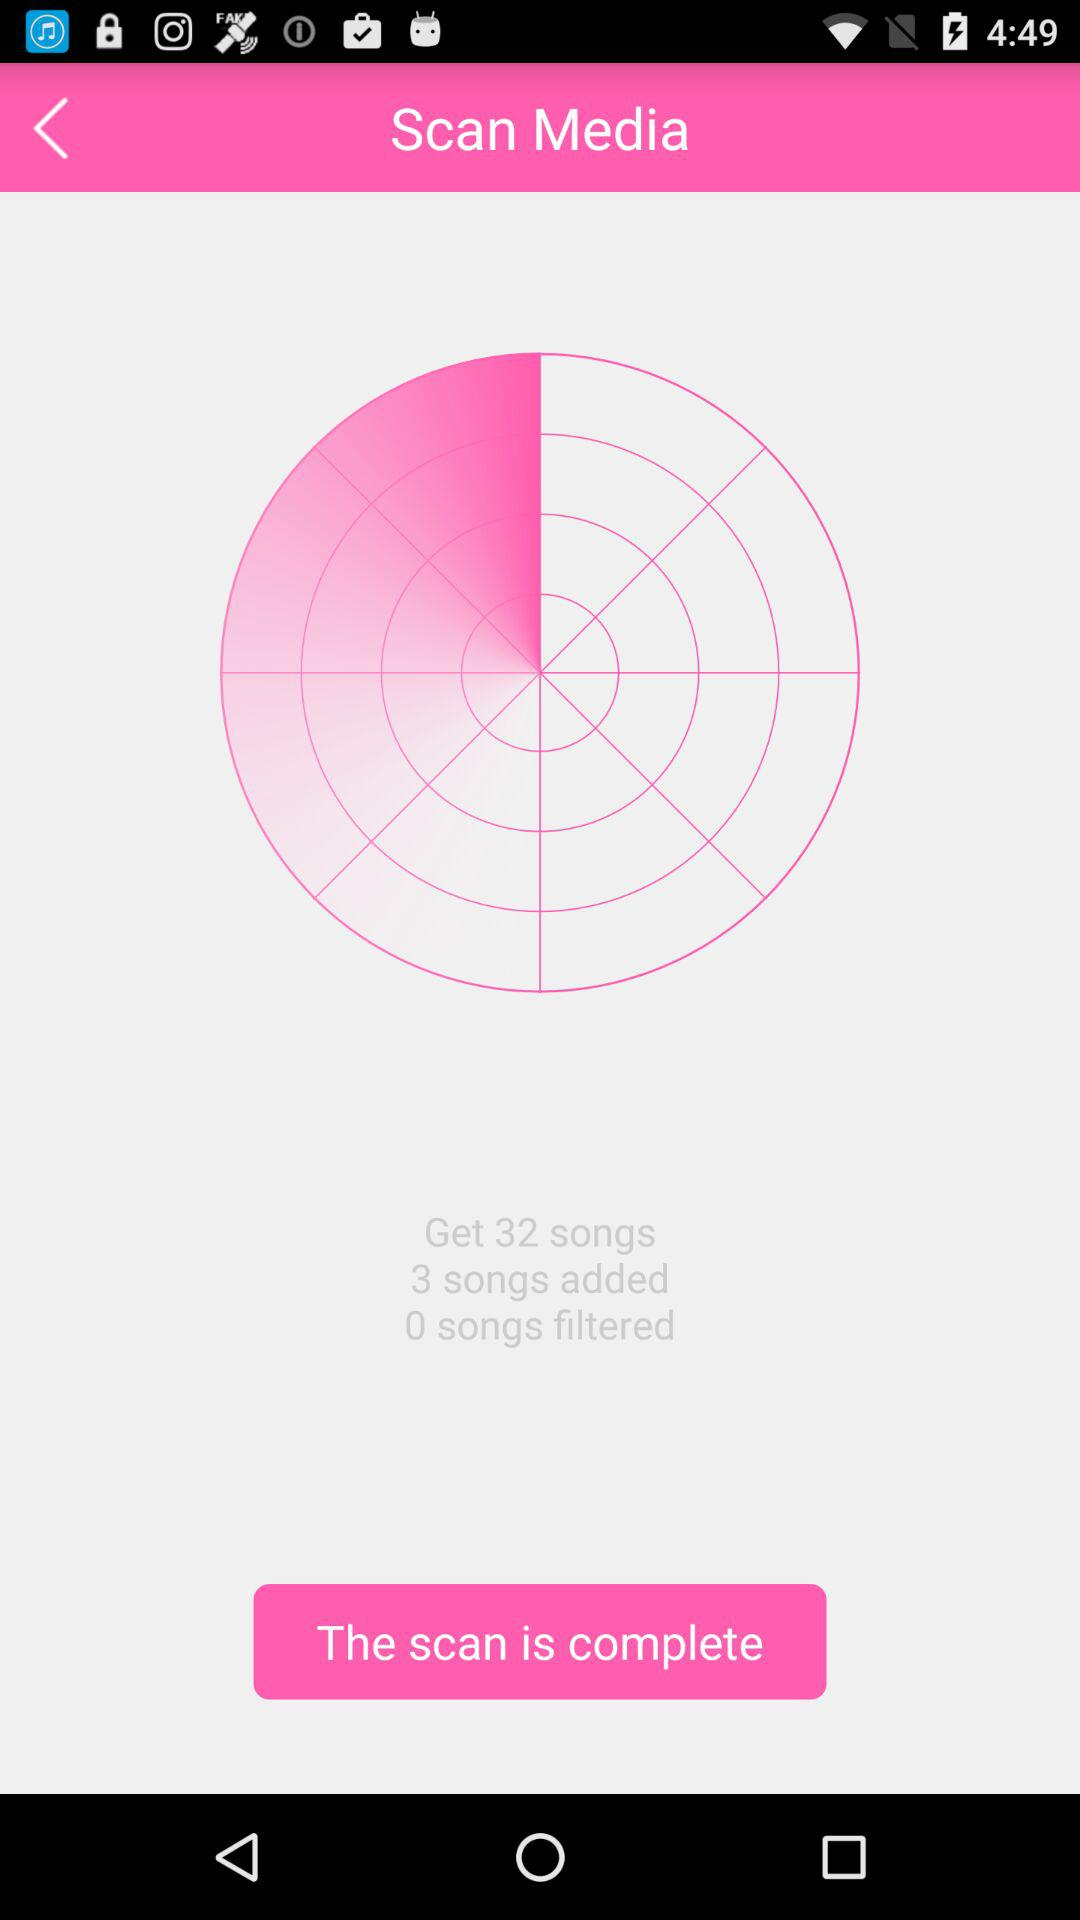How many songs have been added?
Answer the question using a single word or phrase. 3 